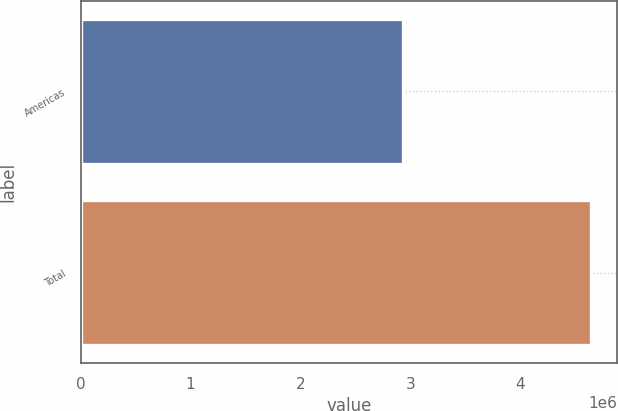<chart> <loc_0><loc_0><loc_500><loc_500><bar_chart><fcel>Americas<fcel>Total<nl><fcel>2.93503e+06<fcel>4.64541e+06<nl></chart> 